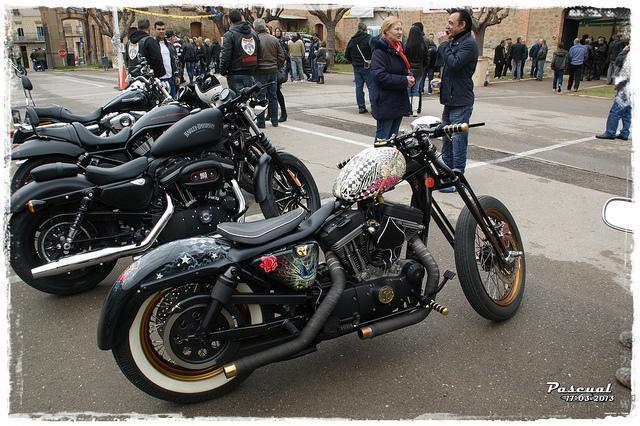How many motorcycles are in the photo?
Give a very brief answer. 4. How many people are visible?
Give a very brief answer. 4. How many kites are in the sky?
Give a very brief answer. 0. 